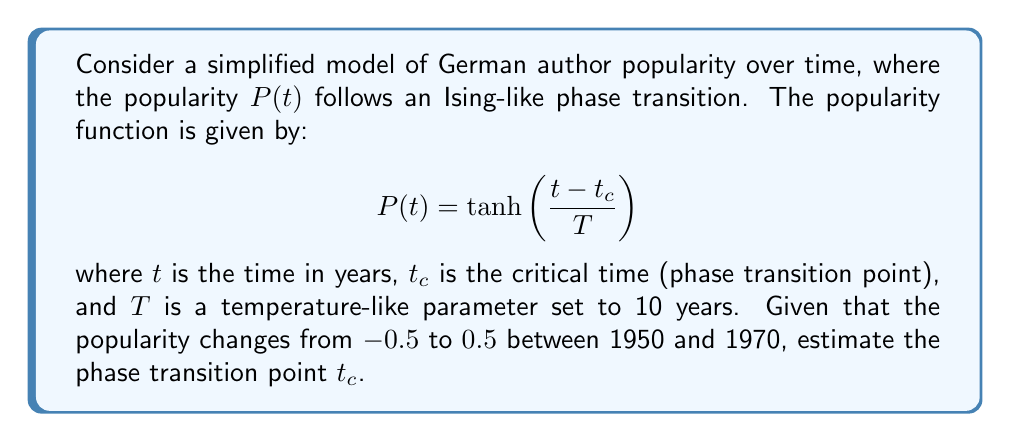Show me your answer to this math problem. To solve this problem, we'll follow these steps:

1) We know that the popularity changes from -0.5 to 0.5 between 1950 and 1970. Let's use these points:

   At $t_1 = 1950$, $P(t_1) = -0.5$
   At $t_2 = 1970$, $P(t_2) = 0.5$

2) We can write two equations using the given popularity function:

   $-0.5 = \tanh\left(\frac{1950 - t_c}{10}\right)$
   $0.5 = \tanh\left(\frac{1970 - t_c}{10}\right)$

3) The inverse function of $\tanh$ is $\text{arctanh}$. Applying this to both equations:

   $\text{arctanh}(-0.5) = \frac{1950 - t_c}{10}$
   $\text{arctanh}(0.5) = \frac{1970 - t_c}{10}$

4) Simplify:

   $-0.5493 = \frac{1950 - t_c}{10}$
   $0.5493 = \frac{1970 - t_c}{10}$

5) Multiply both sides by 10:

   $-5.493 = 1950 - t_c$
   $5.493 = 1970 - t_c$

6) Solve for $t_c$:

   $t_c = 1950 + 5.493 = 1955.493$
   $t_c = 1970 - 5.493 = 1964.507$

7) Take the average of these two values to estimate $t_c$:

   $t_c = \frac{1955.493 + 1964.507}{2} = 1960$

Therefore, the estimated phase transition point is 1960.
Answer: 1960 